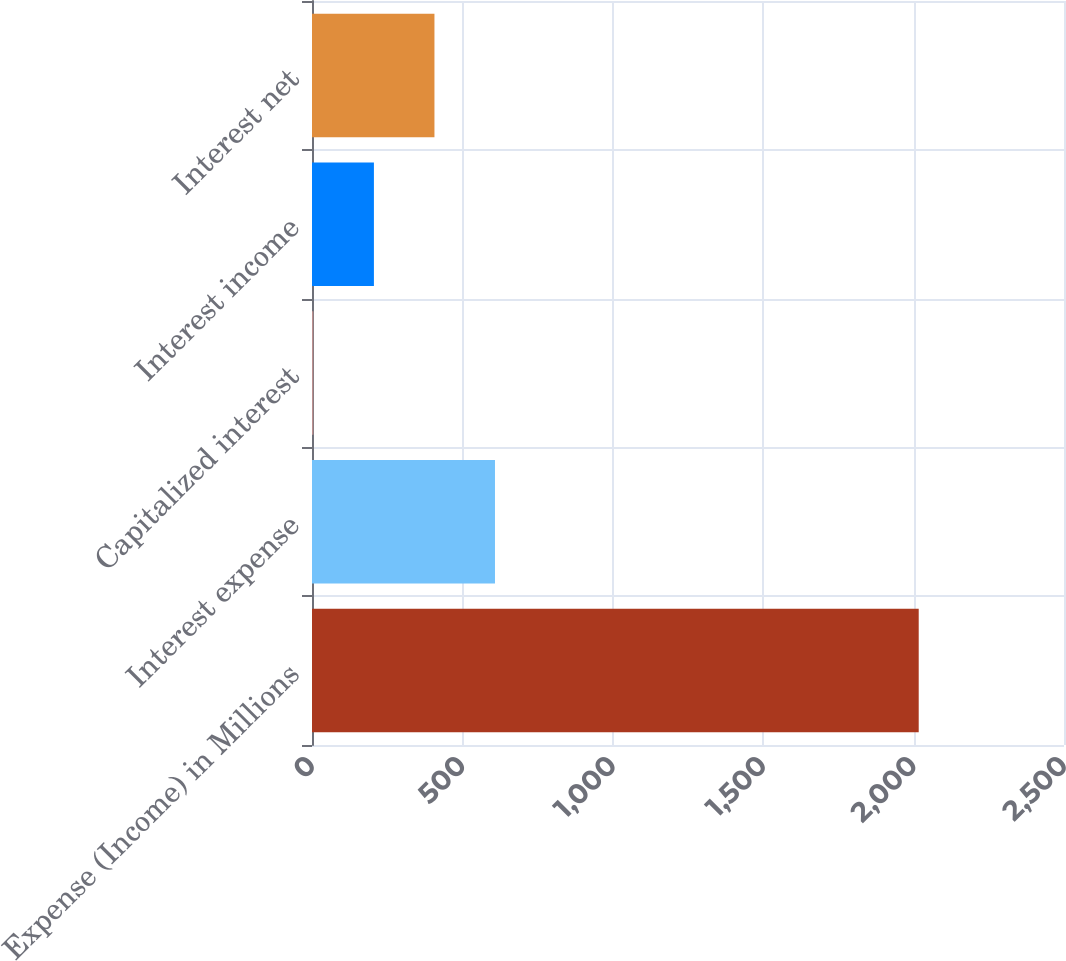Convert chart. <chart><loc_0><loc_0><loc_500><loc_500><bar_chart><fcel>Expense (Income) in Millions<fcel>Interest expense<fcel>Capitalized interest<fcel>Interest income<fcel>Interest net<nl><fcel>2017<fcel>608.32<fcel>4.6<fcel>205.84<fcel>407.08<nl></chart> 